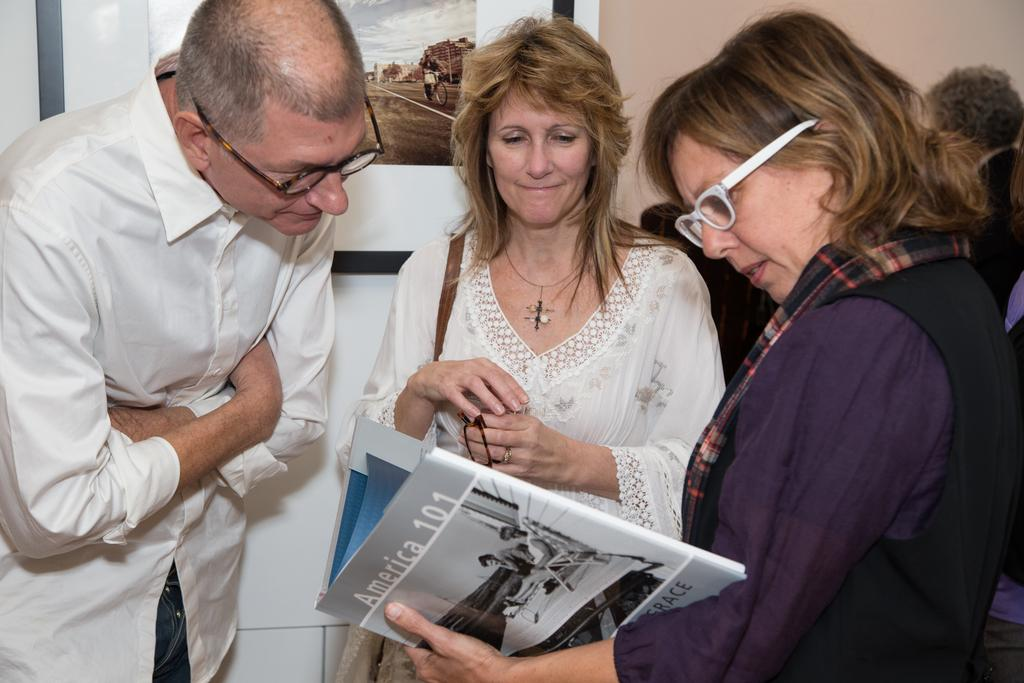What is the main subject of the image? The main subject of the image is a group of people standing. Can you describe what one of the individuals is holding? Yes, there is a woman holding a book in her hands. What can be seen in the background of the image? There is a photo frame attached to the wall in the background of the image. What type of silk fabric is draped over the woman's shoulder in the image? There is no silk fabric present in the image. Can you describe the kiss between the two individuals in the image? There is no kiss between any individuals in the image. 